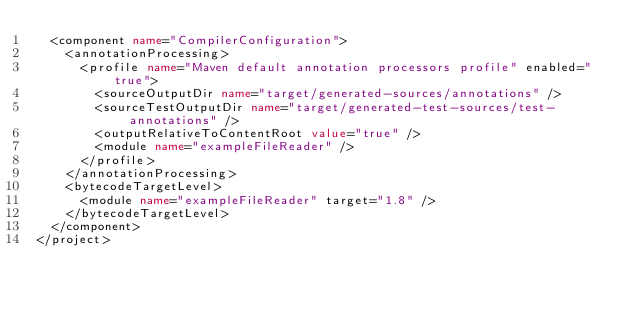Convert code to text. <code><loc_0><loc_0><loc_500><loc_500><_XML_>  <component name="CompilerConfiguration">
    <annotationProcessing>
      <profile name="Maven default annotation processors profile" enabled="true">
        <sourceOutputDir name="target/generated-sources/annotations" />
        <sourceTestOutputDir name="target/generated-test-sources/test-annotations" />
        <outputRelativeToContentRoot value="true" />
        <module name="exampleFileReader" />
      </profile>
    </annotationProcessing>
    <bytecodeTargetLevel>
      <module name="exampleFileReader" target="1.8" />
    </bytecodeTargetLevel>
  </component>
</project></code> 